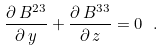Convert formula to latex. <formula><loc_0><loc_0><loc_500><loc_500>\frac { \partial \, B ^ { 2 3 } } { \partial \, y } + \frac { \partial \, B ^ { 3 3 } } { \partial \, z } = 0 \ .</formula> 